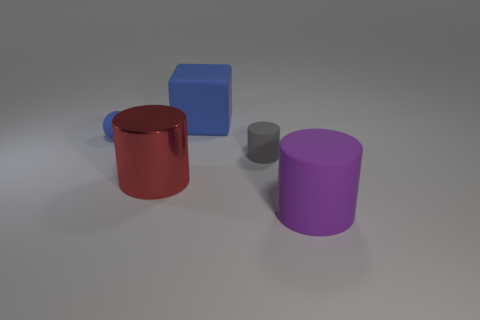There is a tiny cylinder; are there any large cylinders right of it?
Offer a terse response. Yes. What is the color of the tiny matte thing that is to the right of the small rubber thing that is on the left side of the tiny thing that is right of the large blue matte block?
Ensure brevity in your answer.  Gray. How many cylinders are both in front of the gray cylinder and behind the purple rubber cylinder?
Provide a short and direct response. 1. How many spheres are either large matte things or big red metal objects?
Your answer should be very brief. 0. Is there a metal block?
Ensure brevity in your answer.  No. How many other things are the same material as the sphere?
Ensure brevity in your answer.  3. What material is the blue object that is the same size as the purple object?
Your answer should be very brief. Rubber. There is a object behind the small blue rubber ball; is its shape the same as the small blue thing?
Give a very brief answer. No. Is the rubber cube the same color as the tiny ball?
Your answer should be compact. Yes. How many things are either objects that are right of the big cube or rubber balls?
Ensure brevity in your answer.  3. 